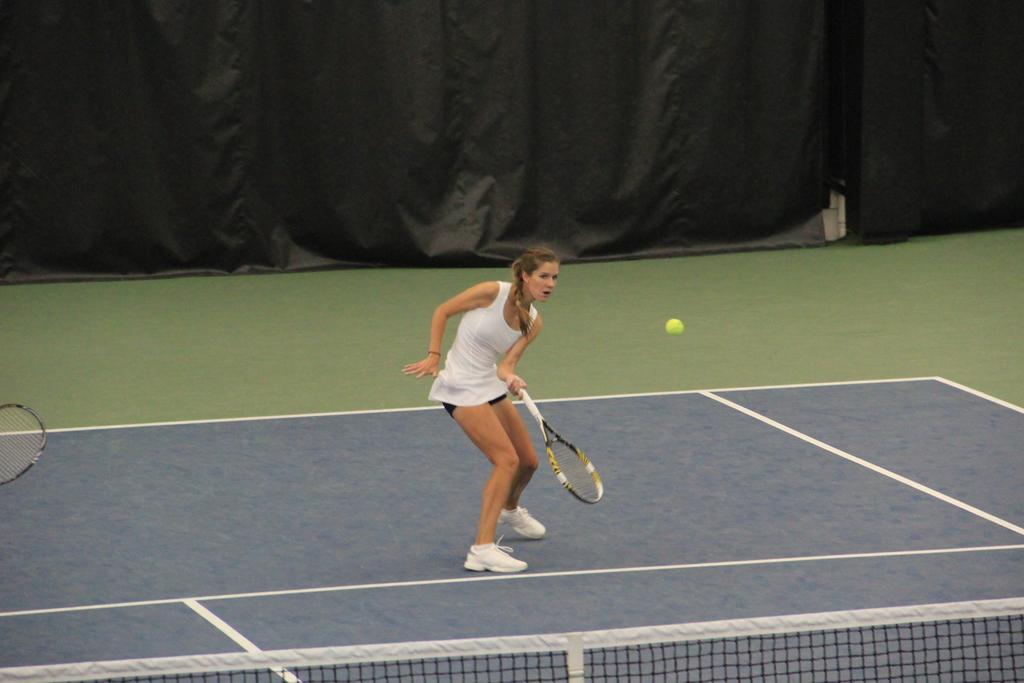How would you summarize this image in a sentence or two? As we can see in the image there is a woman wearing white color dress and white color shoes and playing with shuttle. 